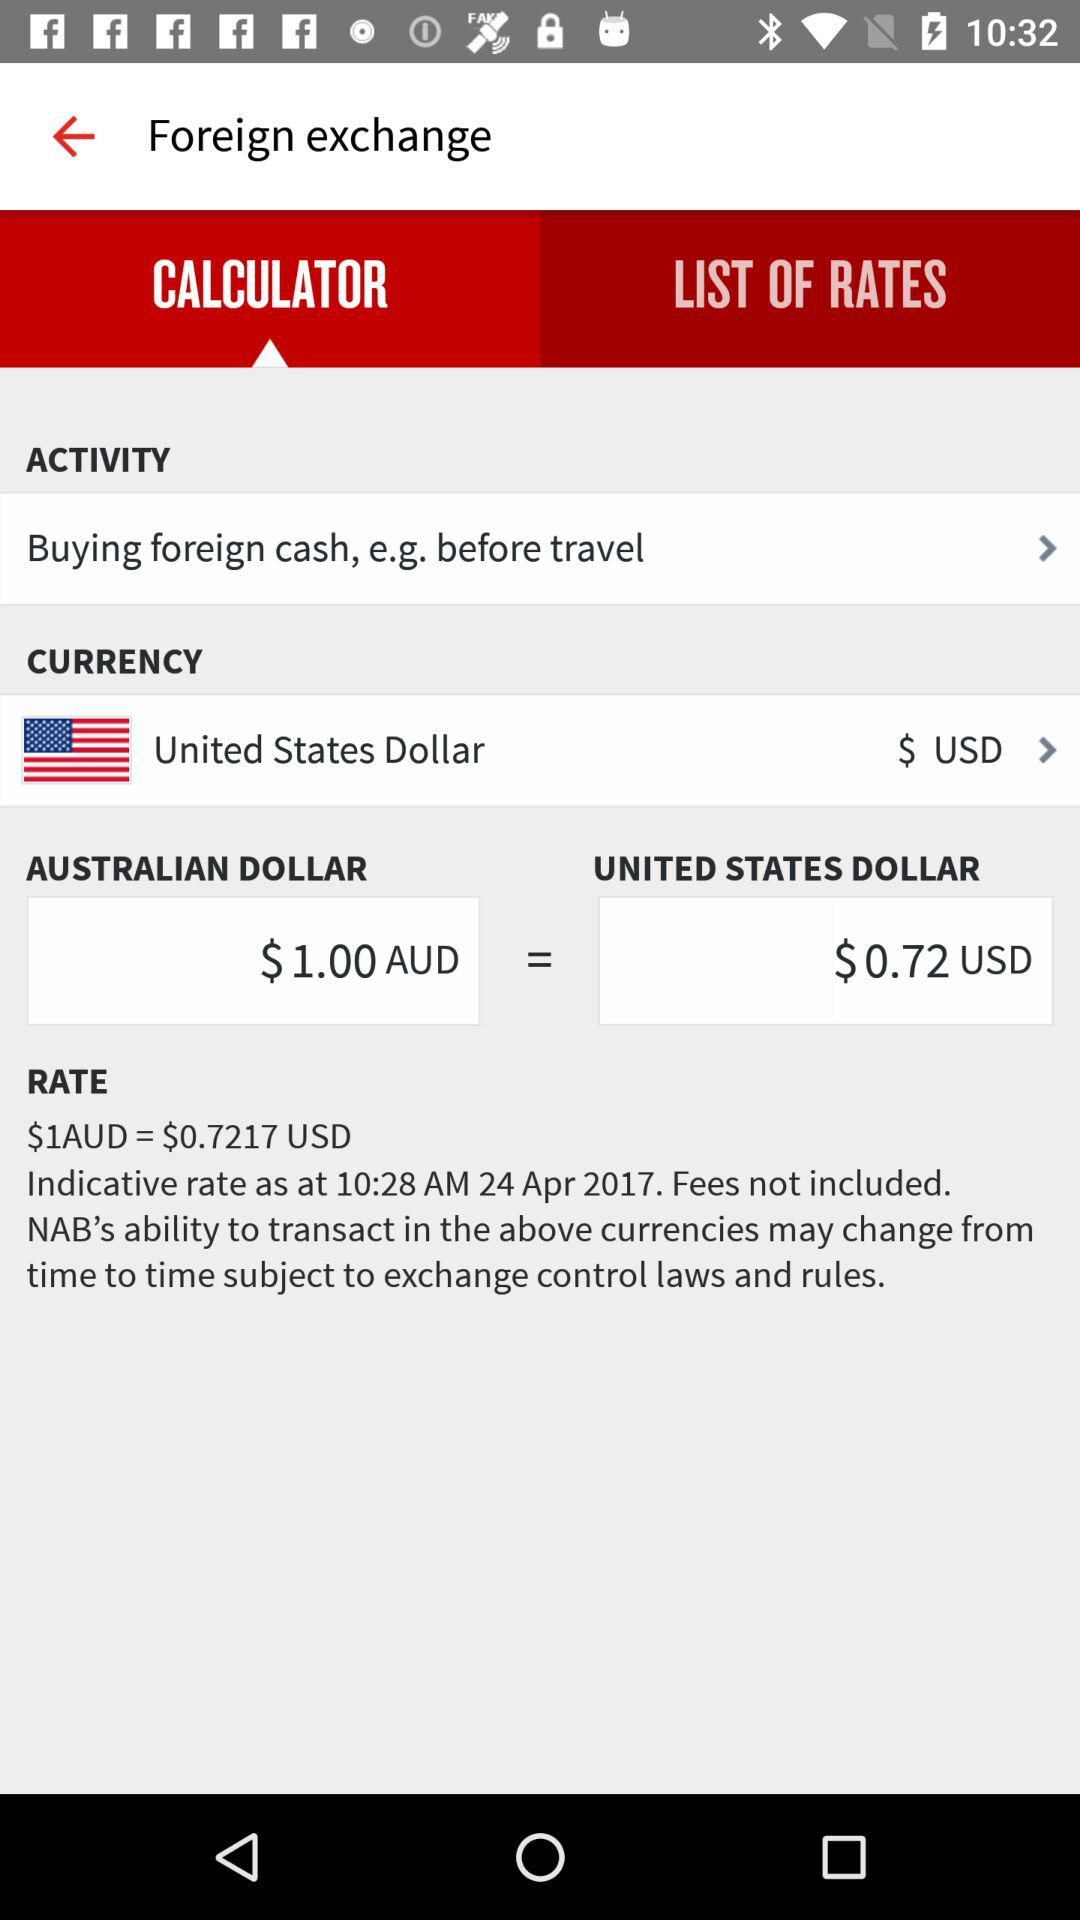How many more dollars does $1AUD equal than $1USD?
Answer the question using a single word or phrase. 0.28 